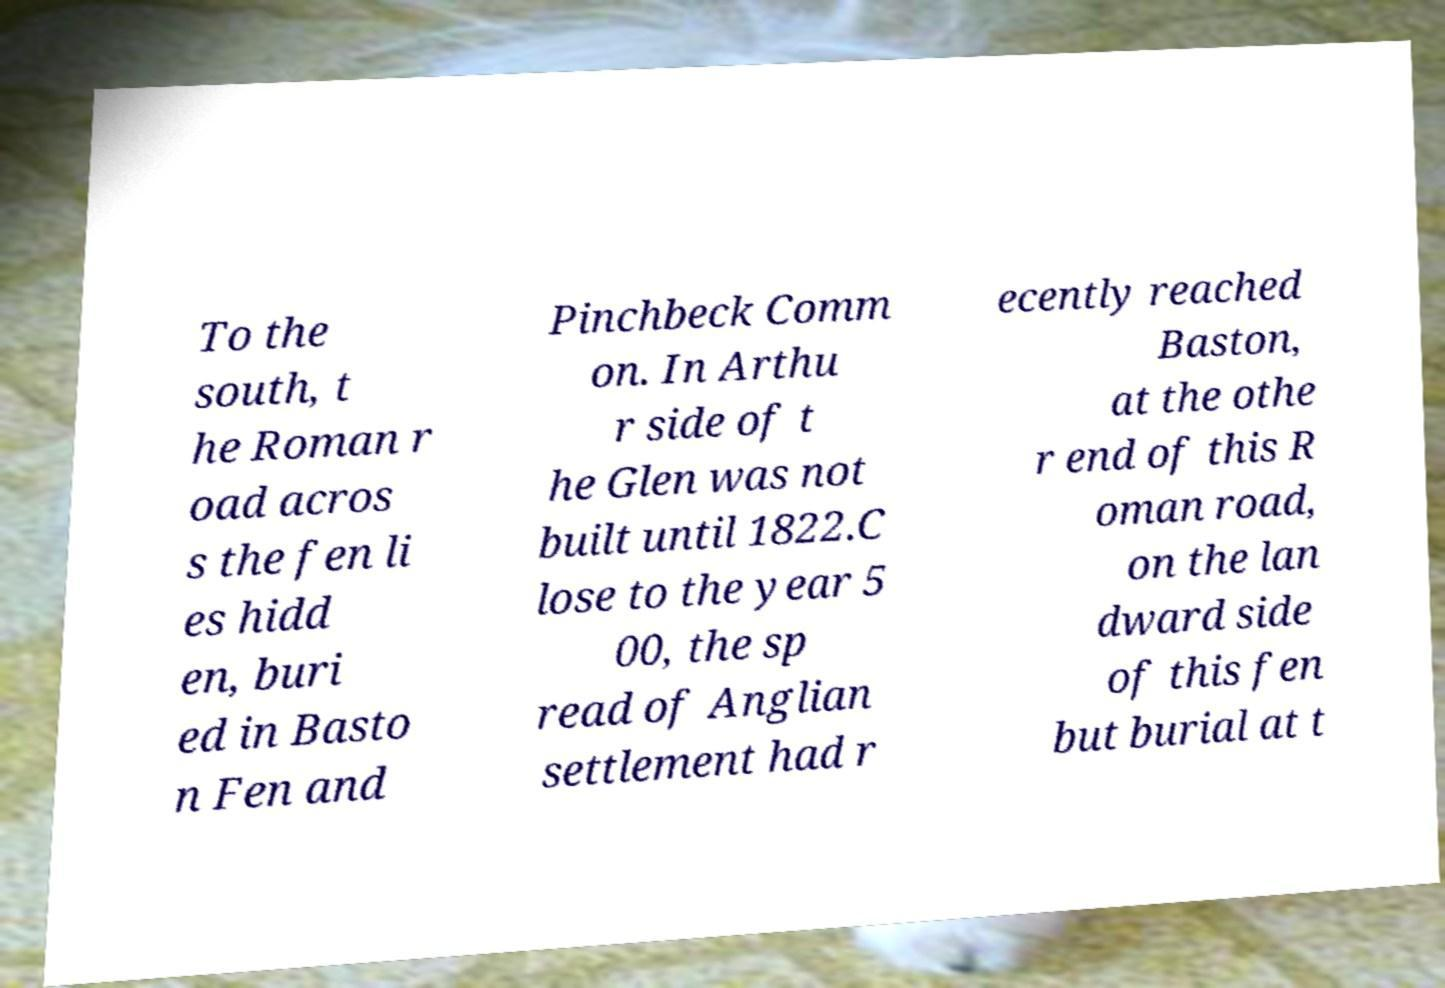Please identify and transcribe the text found in this image. To the south, t he Roman r oad acros s the fen li es hidd en, buri ed in Basto n Fen and Pinchbeck Comm on. In Arthu r side of t he Glen was not built until 1822.C lose to the year 5 00, the sp read of Anglian settlement had r ecently reached Baston, at the othe r end of this R oman road, on the lan dward side of this fen but burial at t 